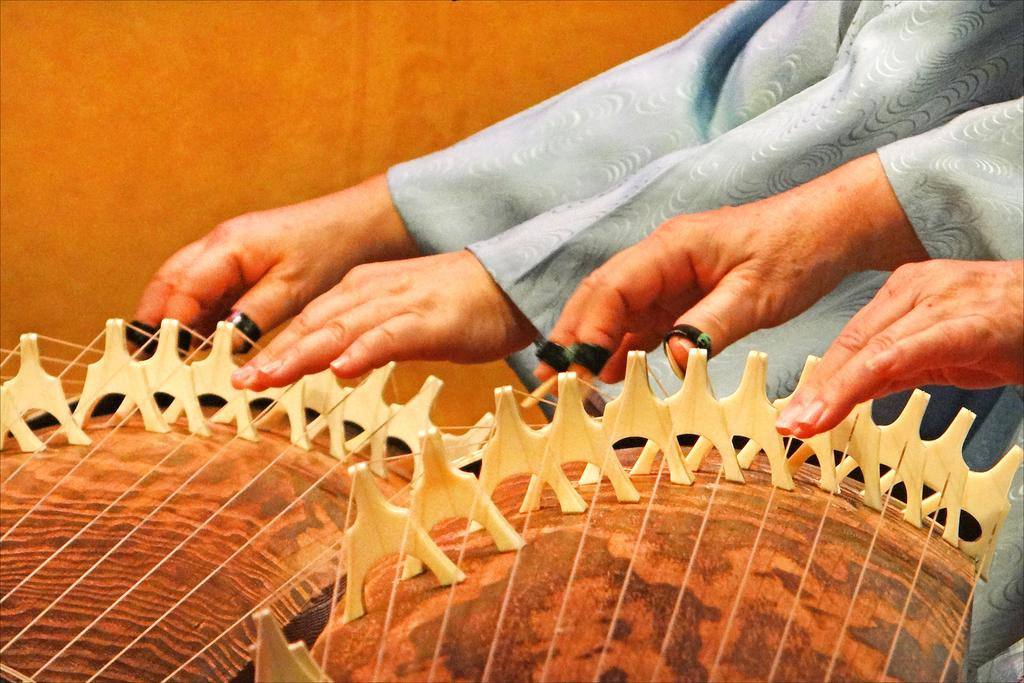What are the people in the image doing? The people in the image are playing musical instruments. What can be observed about the background of the image? The background color is brown. What type of crayon is being used by the people in the image? There is no crayon present in the image; the people are playing musical instruments. Who is the partner of the person playing the guitar in the image? There is no information about partners or relationships between the people in the image, as the focus is on their musical activities. 